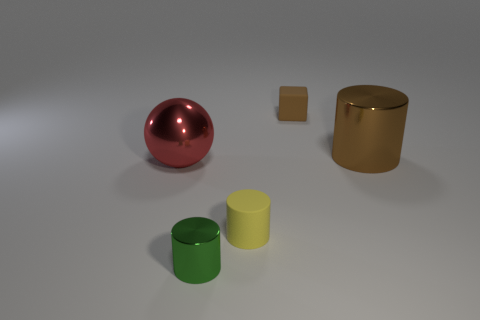Add 4 green shiny objects. How many objects exist? 9 Subtract all balls. How many objects are left? 4 Subtract all small yellow things. Subtract all cyan matte blocks. How many objects are left? 4 Add 2 red balls. How many red balls are left? 3 Add 3 tiny brown metal cylinders. How many tiny brown metal cylinders exist? 3 Subtract 0 cyan cylinders. How many objects are left? 5 